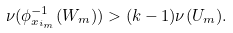Convert formula to latex. <formula><loc_0><loc_0><loc_500><loc_500>\nu ( \phi _ { x _ { i _ { m } } } ^ { - 1 } ( W _ { m } ) ) > ( k - 1 ) \nu ( U _ { m } ) .</formula> 